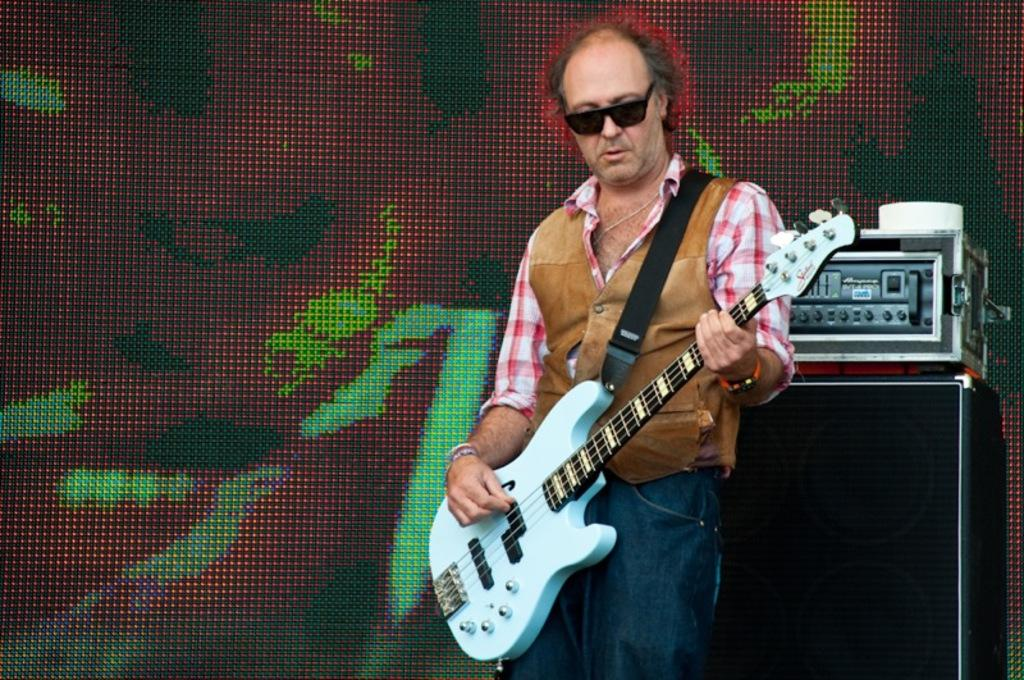What can be seen on the black box in the background of the image? There is a device on a black box in the background of the image. Who is present in the image? There is a man in the image. What is the man wearing? The man is wearing goggles. What is the man doing in the image? The man is standing and playing a guitar. What type of education is the man receiving in the image? There is no indication in the image that the man is receiving any education. What kind of sheet is covering the guitar in the image? There is no sheet covering the guitar in the image; the man is playing it without any covering. 